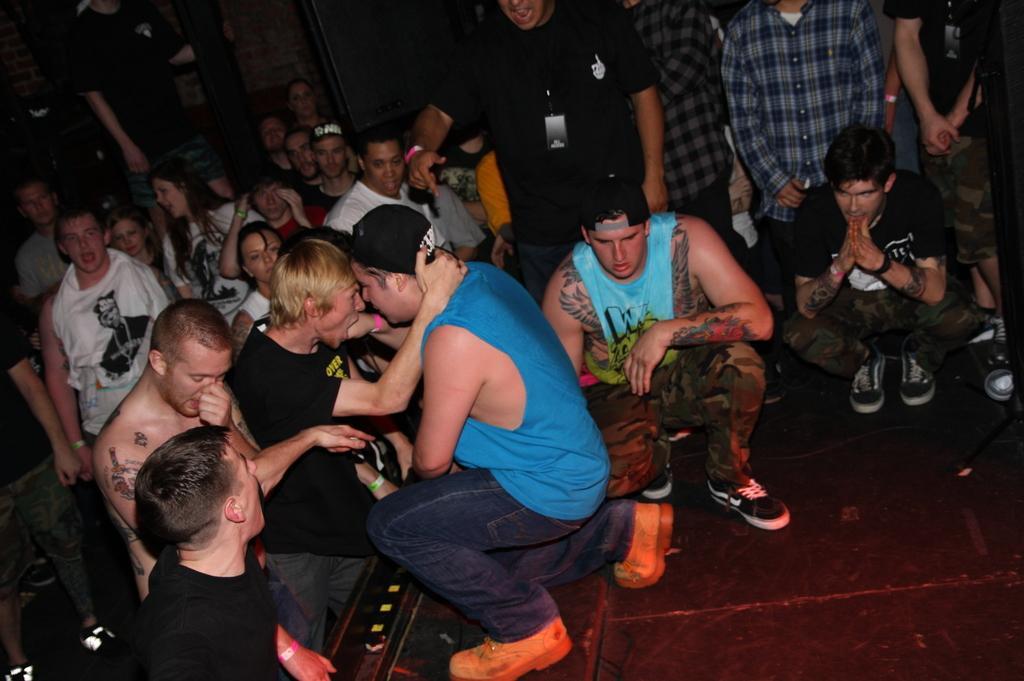Could you give a brief overview of what you see in this image? In this image there are group of persons standing and squatting. 